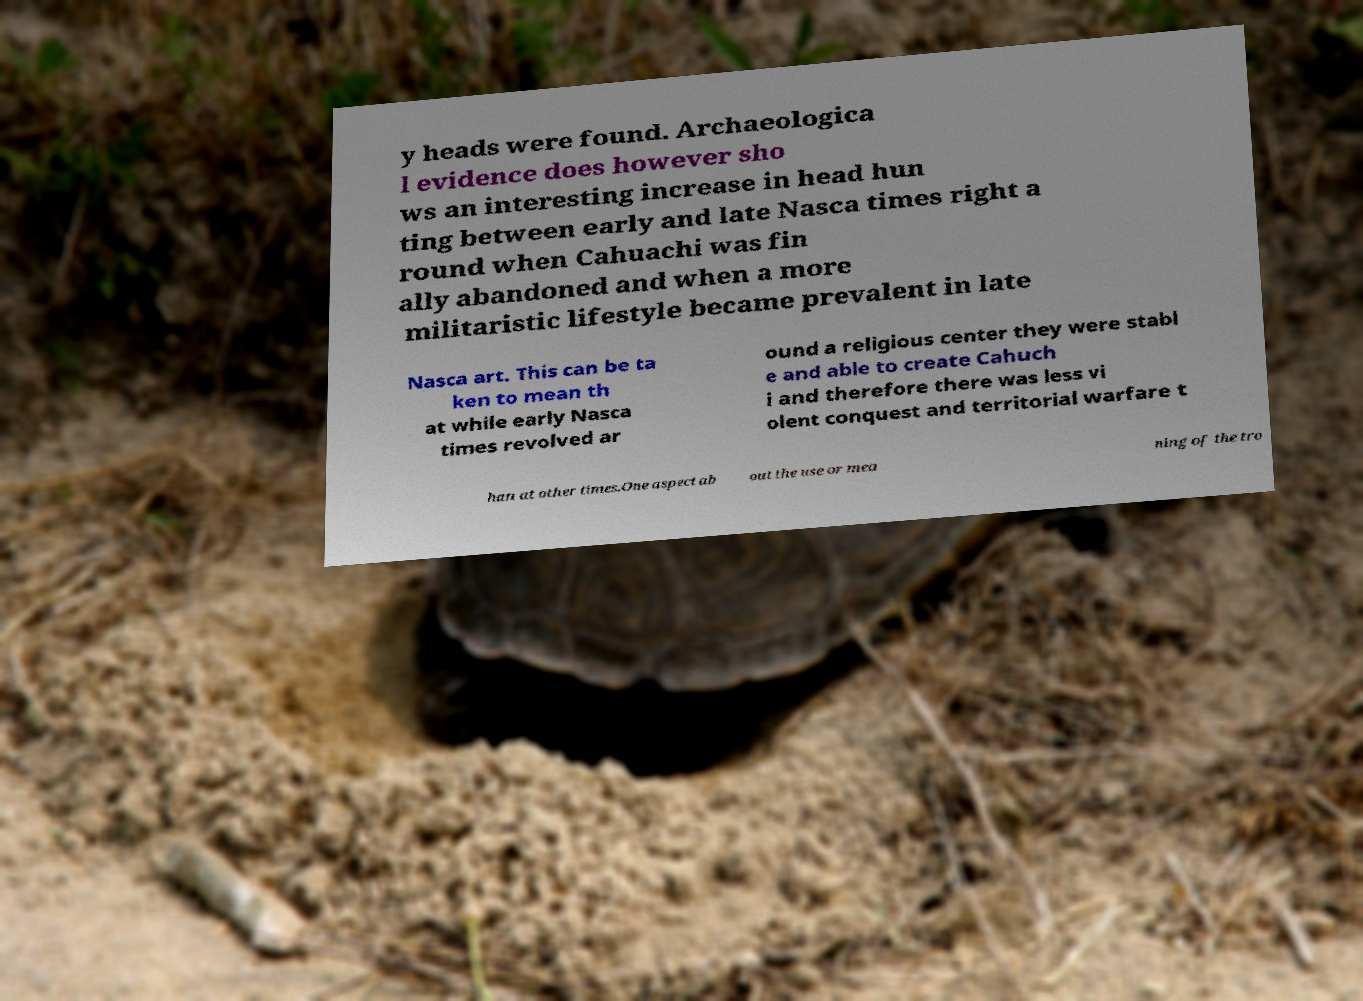Please identify and transcribe the text found in this image. y heads were found. Archaeologica l evidence does however sho ws an interesting increase in head hun ting between early and late Nasca times right a round when Cahuachi was fin ally abandoned and when a more militaristic lifestyle became prevalent in late Nasca art. This can be ta ken to mean th at while early Nasca times revolved ar ound a religious center they were stabl e and able to create Cahuch i and therefore there was less vi olent conquest and territorial warfare t han at other times.One aspect ab out the use or mea ning of the tro 